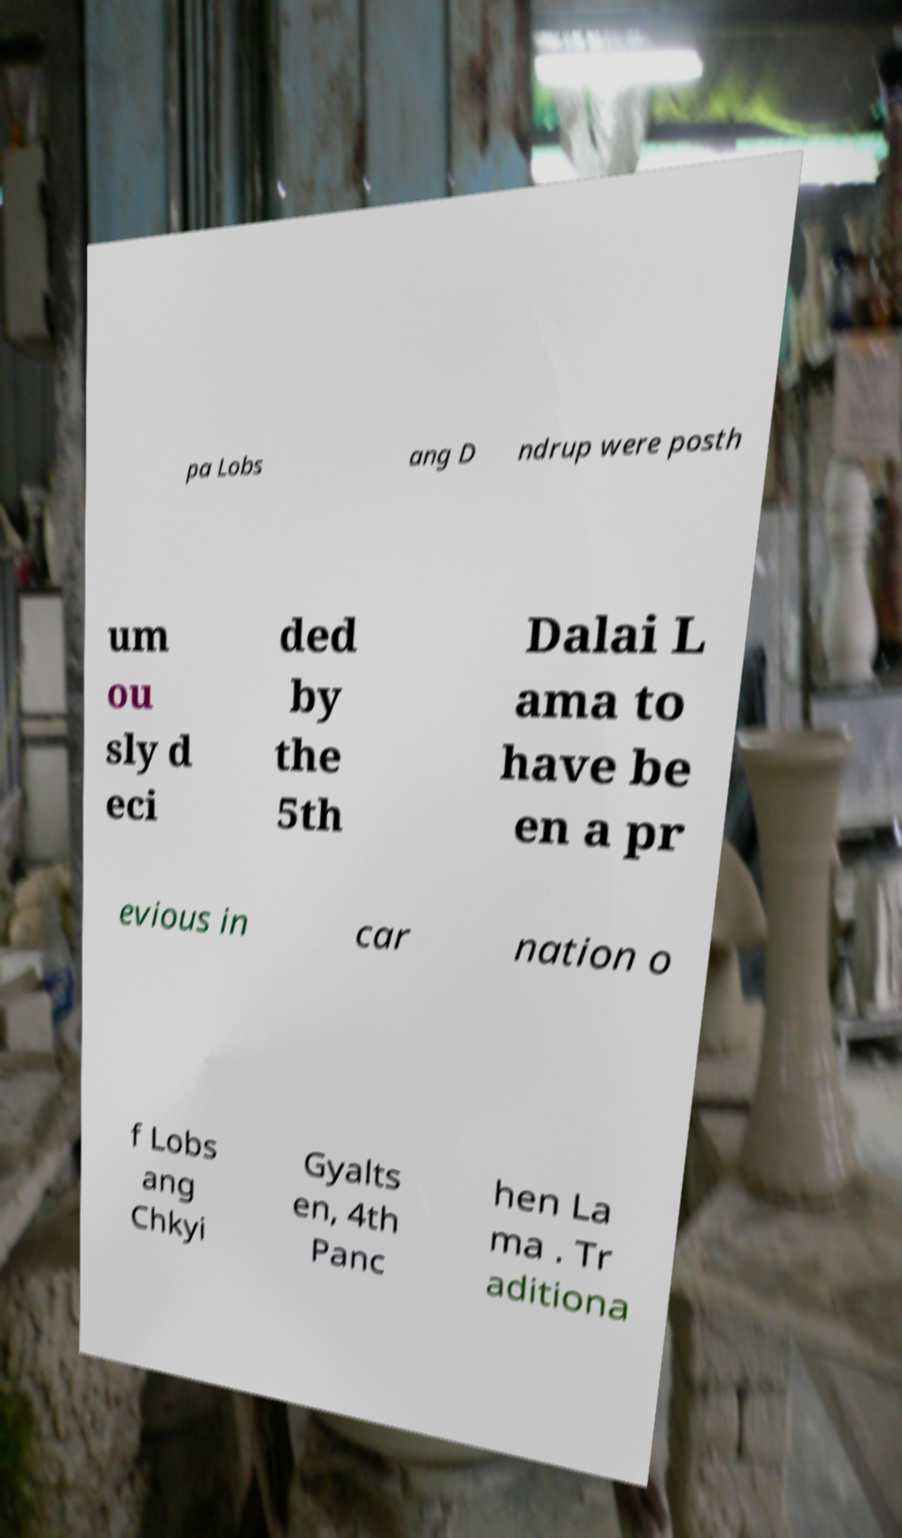Please identify and transcribe the text found in this image. pa Lobs ang D ndrup were posth um ou sly d eci ded by the 5th Dalai L ama to have be en a pr evious in car nation o f Lobs ang Chkyi Gyalts en, 4th Panc hen La ma . Tr aditiona 